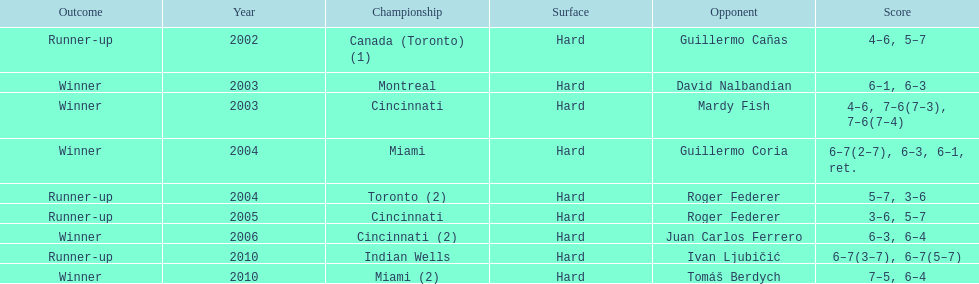How many championships took place in toronto or montreal? 3. 